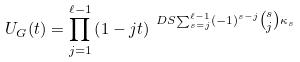<formula> <loc_0><loc_0><loc_500><loc_500>U _ { G } ( t ) = \prod _ { j = 1 } ^ { \ell - 1 } \left ( 1 - j t \right ) ^ { \ D S { \sum _ { s = j } ^ { \ell - 1 } ( - 1 ) ^ { s - j } \tbinom { s } { j } \kappa _ { s } } }</formula> 